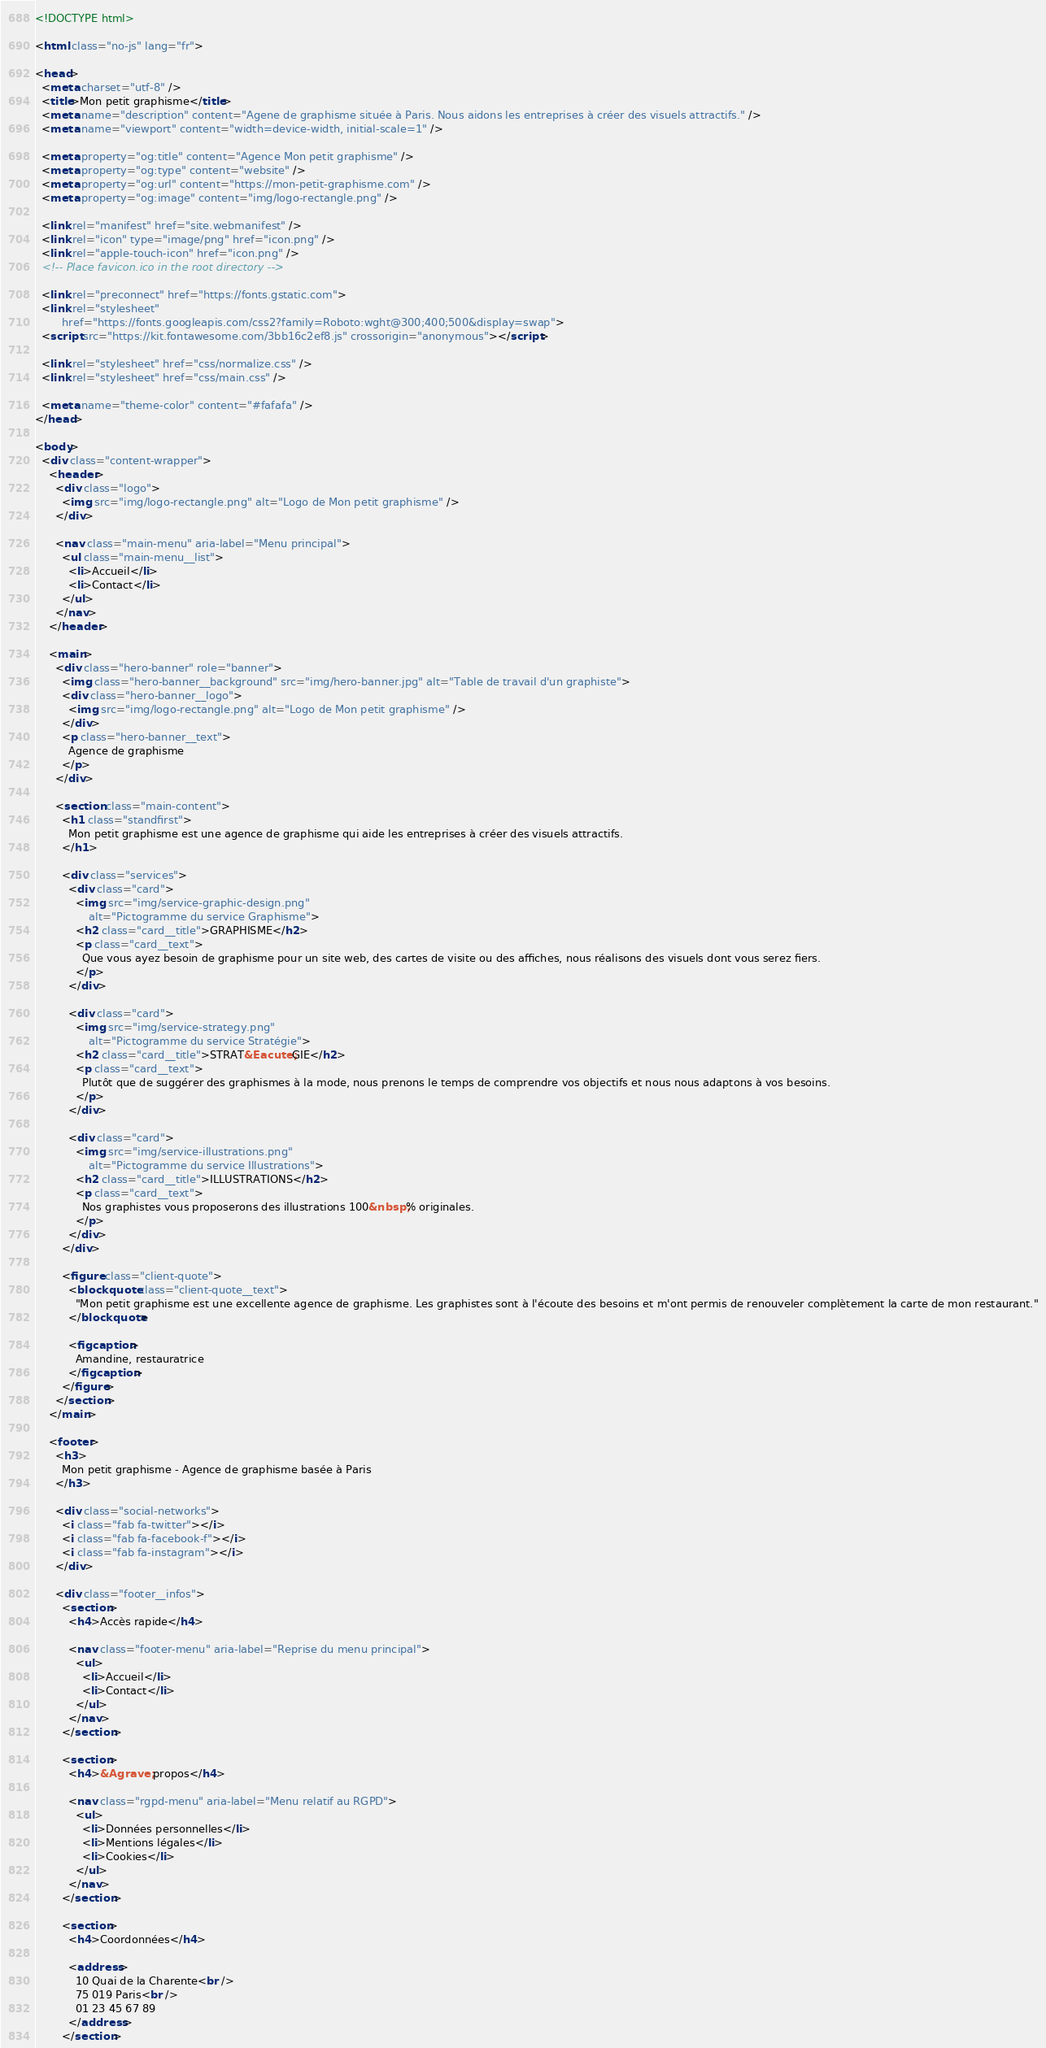Convert code to text. <code><loc_0><loc_0><loc_500><loc_500><_HTML_><!DOCTYPE html>

<html class="no-js" lang="fr">

<head>
  <meta charset="utf-8" />
  <title>Mon petit graphisme</title>
  <meta name="description" content="Agene de graphisme située à Paris. Nous aidons les entreprises à créer des visuels attractifs." />
  <meta name="viewport" content="width=device-width, initial-scale=1" />

  <meta property="og:title" content="Agence Mon petit graphisme" />
  <meta property="og:type" content="website" />
  <meta property="og:url" content="https://mon-petit-graphisme.com" />
  <meta property="og:image" content="img/logo-rectangle.png" />

  <link rel="manifest" href="site.webmanifest" />
  <link rel="icon" type="image/png" href="icon.png" />
  <link rel="apple-touch-icon" href="icon.png" />
  <!-- Place favicon.ico in the root directory -->

  <link rel="preconnect" href="https://fonts.gstatic.com">
  <link rel="stylesheet" 
        href="https://fonts.googleapis.com/css2?family=Roboto:wght@300;400;500&display=swap">
  <script src="https://kit.fontawesome.com/3bb16c2ef8.js" crossorigin="anonymous"></script>

  <link rel="stylesheet" href="css/normalize.css" />
  <link rel="stylesheet" href="css/main.css" />

  <meta name="theme-color" content="#fafafa" />
</head>

<body>
  <div class="content-wrapper">
    <header>
      <div class="logo">
        <img src="img/logo-rectangle.png" alt="Logo de Mon petit graphisme" />
      </div>

      <nav class="main-menu" aria-label="Menu principal">
        <ul class="main-menu__list">
          <li>Accueil</li>
          <li>Contact</li>
        </ul>
      </nav>
    </header>

    <main>
      <div class="hero-banner" role="banner">
        <img class="hero-banner__background" src="img/hero-banner.jpg" alt="Table de travail d'un graphiste">
        <div class="hero-banner__logo">
          <img src="img/logo-rectangle.png" alt="Logo de Mon petit graphisme" />
        </div>
        <p class="hero-banner__text">
          Agence de graphisme
        </p>
      </div>

      <section class="main-content">
        <h1 class="standfirst">
          Mon petit graphisme est une agence de graphisme qui aide les entreprises à créer des visuels attractifs.
        </h1>

        <div class="services">
          <div class="card">
            <img src="img/service-graphic-design.png" 
                alt="Pictogramme du service Graphisme">
            <h2 class="card__title">GRAPHISME</h2>
            <p class="card__text">
              Que vous ayez besoin de graphisme pour un site web, des cartes de visite ou des affiches, nous réalisons des visuels dont vous serez fiers.
            </p>
          </div>

          <div class="card">
            <img src="img/service-strategy.png" 
                alt="Pictogramme du service Stratégie">
            <h2 class="card__title">STRAT&Eacute;GIE</h2>
            <p class="card__text">
              Plutôt que de suggérer des graphismes à la mode, nous prenons le temps de comprendre vos objectifs et nous nous adaptons à vos besoins.
            </p>
          </div>

          <div class="card">
            <img src="img/service-illustrations.png" 
                alt="Pictogramme du service Illustrations">
            <h2 class="card__title">ILLUSTRATIONS</h2>
            <p class="card__text">
              Nos graphistes vous proposerons des illustrations 100&nbsp;% originales.
            </p>
          </div>
        </div>

        <figure class="client-quote">
          <blockquote class="client-quote__text">
            "Mon petit graphisme est une excellente agence de graphisme. Les graphistes sont à l'écoute des besoins et m'ont permis de renouveler complètement la carte de mon restaurant."
          </blockquote>

          <figcaption>
            Amandine, restauratrice
          </figcaption>
        </figure>
      </section>
    </main>

    <footer>
      <h3>
        Mon petit graphisme - Agence de graphisme basée à Paris
      </h3>

      <div class="social-networks">
        <i class="fab fa-twitter"></i>
        <i class="fab fa-facebook-f"></i>
        <i class="fab fa-instagram"></i>
      </div>

      <div class="footer__infos">
        <section>
          <h4>Accès rapide</h4>

          <nav class="footer-menu" aria-label="Reprise du menu principal">
            <ul>
              <li>Accueil</li>
              <li>Contact</li>
            </ul>
          </nav>
        </section>
      
        <section>
          <h4>&Agrave; propos</h4>

          <nav class="rgpd-menu" aria-label="Menu relatif au RGPD">
            <ul>
              <li>Données personnelles</li>
              <li>Mentions légales</li>
              <li>Cookies</li>
            </ul>
          </nav>
        </section>

        <section>
          <h4>Coordonnées</h4>

          <address>
            10 Quai de la Charente<br />
            75 019 Paris<br />
            01 23 45 67 89
          </address>
        </section></code> 